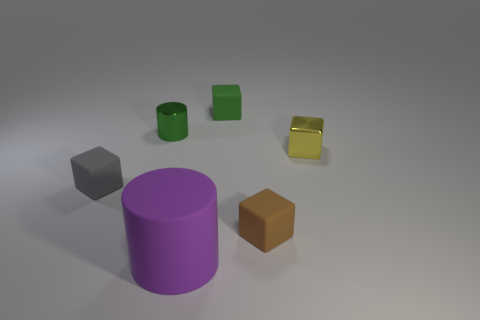Add 4 purple matte things. How many objects exist? 10 Subtract all blocks. How many objects are left? 2 Subtract 0 red blocks. How many objects are left? 6 Subtract all tiny yellow objects. Subtract all large cubes. How many objects are left? 5 Add 4 tiny shiny cubes. How many tiny shiny cubes are left? 5 Add 1 purple matte blocks. How many purple matte blocks exist? 1 